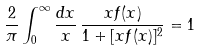Convert formula to latex. <formula><loc_0><loc_0><loc_500><loc_500>\frac { 2 } { \pi } \int _ { 0 } ^ { \infty } \frac { d x } { x } \, \frac { x f ( x ) } { 1 + [ x f ( x ) ] ^ { 2 } } = 1</formula> 